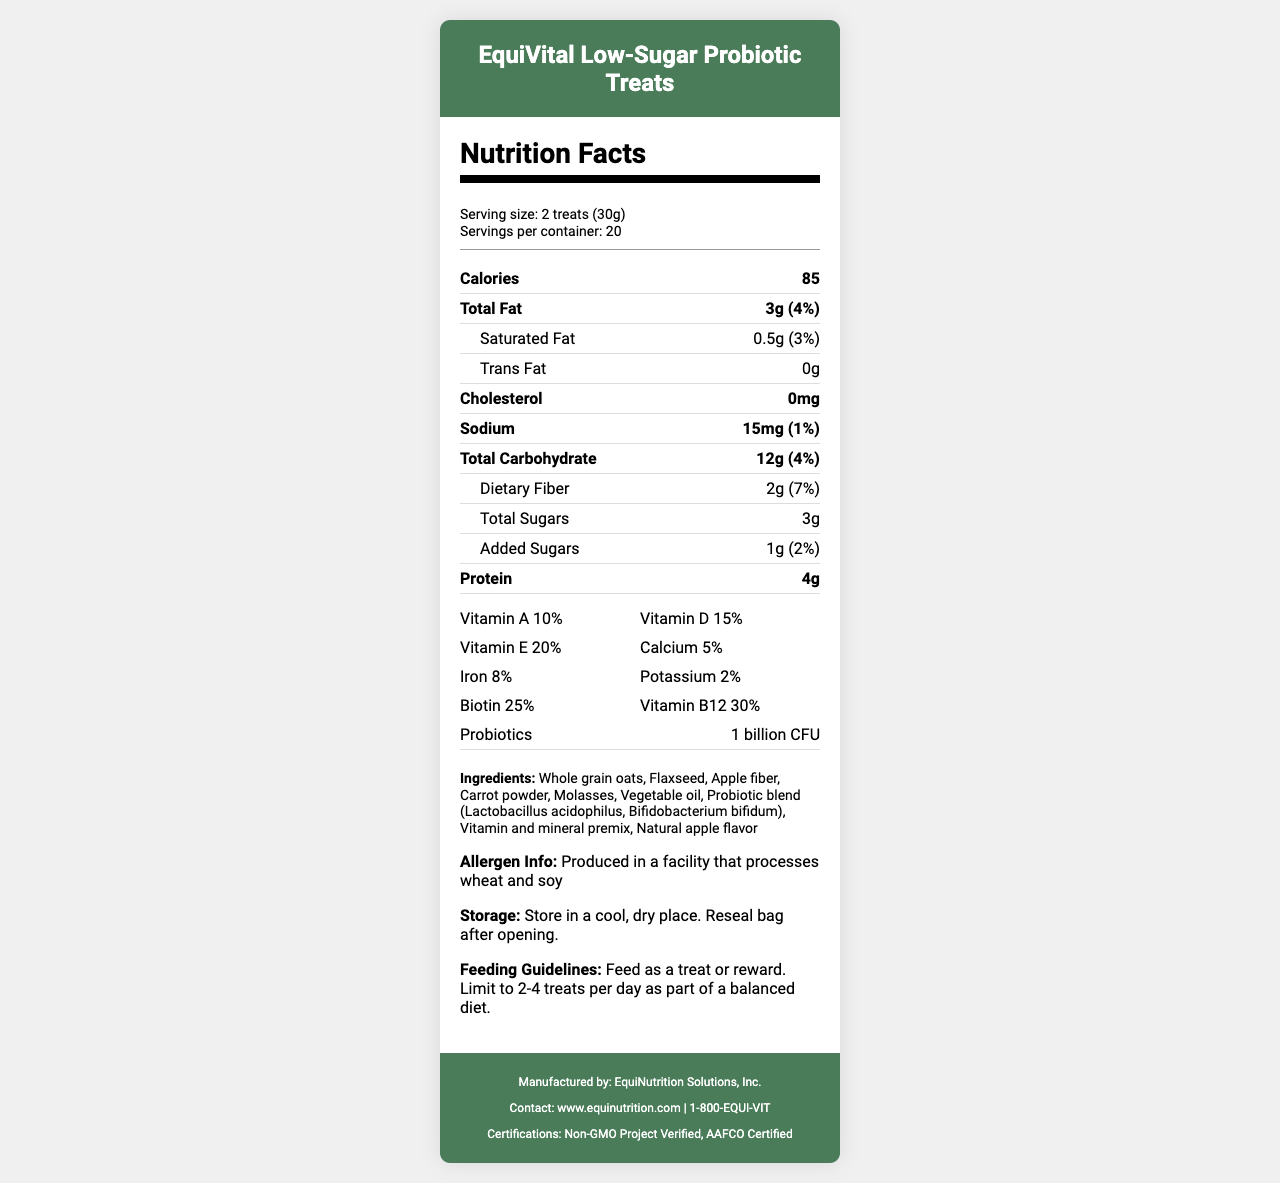what is the serving size of the EquiVital Low-Sugar Probiotic Treats? The serving size is explicitly stated as "2 treats (30g)" in the serving information section.
Answer: 2 treats (30g) how many calories are there per serving? The calories per serving are listed as 85 in the main nutrient section.
Answer: 85 what is the total amount of fat per serving and its daily value percentage? The total amount of fat per serving is 3g, with a daily value percentage of 4%, as provided in the document.
Answer: 3g (4%) list the probiotics included in this treat. The ingredients list includes the probiotic blend composed of Lactobacillus acidophilus and Bifidobacterium bifidum.
Answer: Lactobacillus acidophilus, Bifidobacterium bifidum what certifications does this product have? The footer section lists the certifications: Non-GMO Project Verified and AAFCO Certified.
Answer: Non-GMO Project Verified, AAFCO Certified what vitamins and minerals are present in the treat, and what are their daily values? The vitamins and minerals along with their daily values are listed in the vitamins section.
Answer: Vitamin A 10%, Vitamin D 15%, Vitamin E 20%, Calcium 5%, Iron 8%, Potassium 2%, Biotin 25%, Vitamin B12 30% how should these treats be stored? The storage instructions specify to store in a cool, dry place and reseal the bag after opening.
Answer: Store in a cool, dry place. Reseal bag after opening. which ingredient is listed first in the ingredients list? The ingredients list starts with Whole grain oats.
Answer: Whole grain oats how many treats should you limit to per day for a horse? The feeding guidelines state to limit feeding to 2-4 treats per day.
Answer: 2-4 treats per day does the product contain trans fat? The nutrient row for trans fat lists 0g, indicating that the product contains no trans fat.
Answer: No what is the main ingredient used in the treats? A. Apple fiber B. Flaxseed C. Whole grain oats D. Carrot powder The first ingredient listed is Whole grain oats, indicating it is the main ingredient.
Answer: C which of the following vitamins has the highest daily value percentage in the treats? I. Vitamin A II. Vitamin E III. Vitamin B12 IV. Biotin Vitamin B12 has the highest daily value percentage at 30%.
Answer: III are these treats suitable for horses with wheat or soy allergies? The allergen information states that the product is produced in a facility that processes wheat and soy, which may not be suitable for horses with such allergies.
Answer: No summarize the nutritional content and benefits of EquiVital Low-Sugar Probiotic Treats. The nutritional content includes low sugar and added dietary fiber. The vitamins and probiotics support overall health, making it a wholesome treat for horses.
Answer: EquiVital Low-Sugar Probiotic Treats are a low-sugar horse treat with added vitamins and probiotics. Each serving size of 2 treats (30g) contains 85 calories, 3g of total fat, and 12g of carbohydrates, including 2g of dietary fiber and 3g of sugars. The treats are enriched with vitamins A, D, E, and B12, as well as minerals like calcium, iron, potassium, and biotin, and contain 1 billion CFU of probiotics. are there any artificial flavors in the treat? The document lists "Natural apple flavor" in the ingredients, but it doesn't specify whether other artificial flavors are present or absent.
Answer: Not enough information 